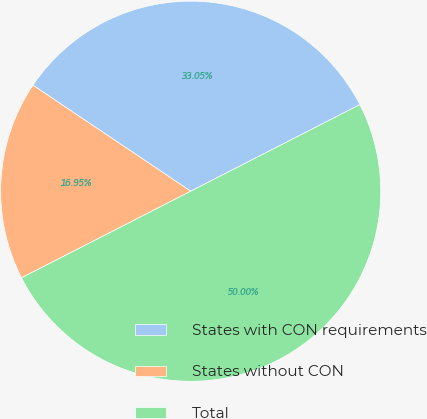Convert chart to OTSL. <chart><loc_0><loc_0><loc_500><loc_500><pie_chart><fcel>States with CON requirements<fcel>States without CON<fcel>Total<nl><fcel>33.05%<fcel>16.95%<fcel>50.0%<nl></chart> 